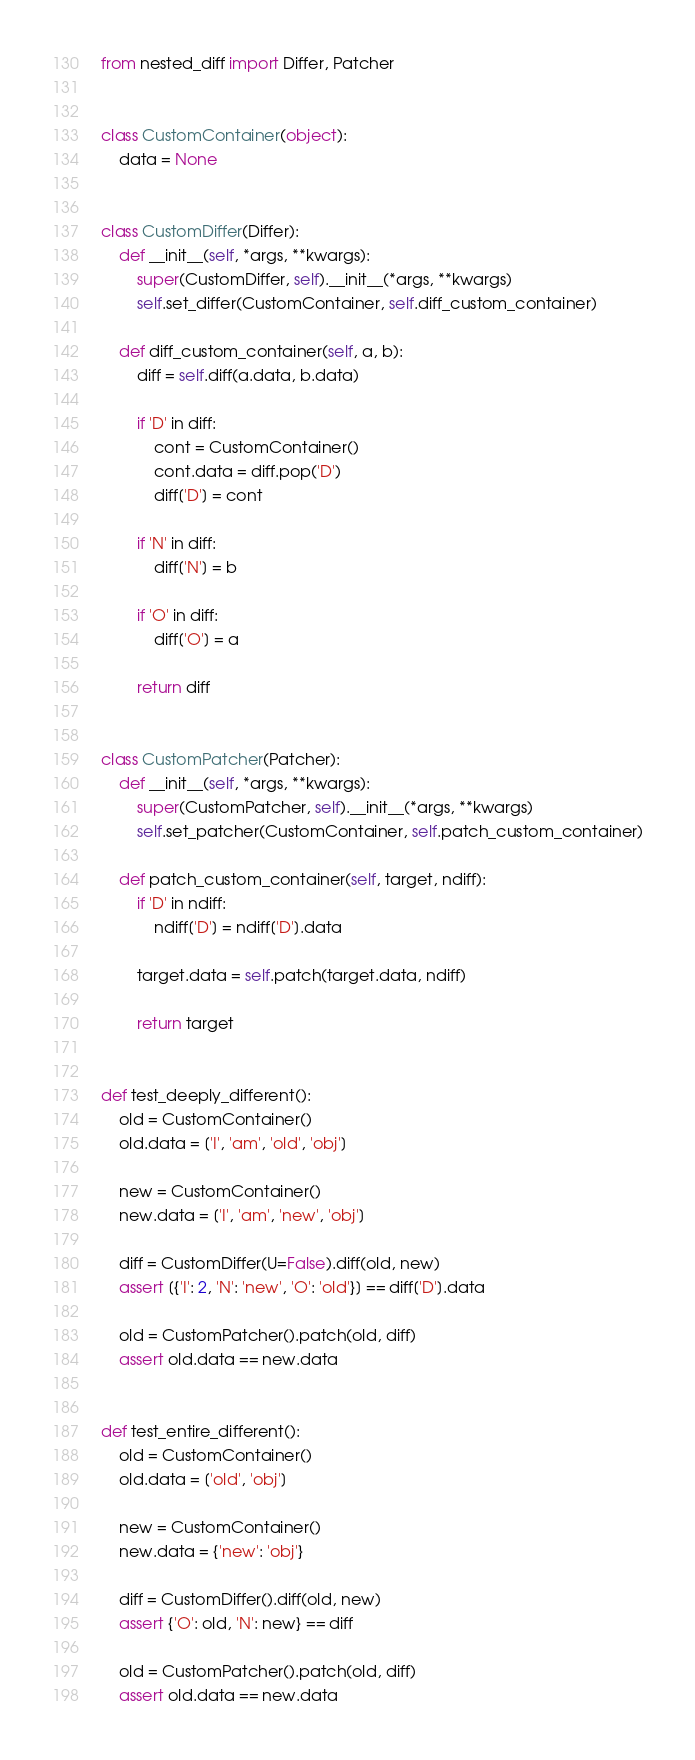Convert code to text. <code><loc_0><loc_0><loc_500><loc_500><_Python_>from nested_diff import Differ, Patcher


class CustomContainer(object):
    data = None


class CustomDiffer(Differ):
    def __init__(self, *args, **kwargs):
        super(CustomDiffer, self).__init__(*args, **kwargs)
        self.set_differ(CustomContainer, self.diff_custom_container)

    def diff_custom_container(self, a, b):
        diff = self.diff(a.data, b.data)

        if 'D' in diff:
            cont = CustomContainer()
            cont.data = diff.pop('D')
            diff['D'] = cont

        if 'N' in diff:
            diff['N'] = b

        if 'O' in diff:
            diff['O'] = a

        return diff


class CustomPatcher(Patcher):
    def __init__(self, *args, **kwargs):
        super(CustomPatcher, self).__init__(*args, **kwargs)
        self.set_patcher(CustomContainer, self.patch_custom_container)

    def patch_custom_container(self, target, ndiff):
        if 'D' in ndiff:
            ndiff['D'] = ndiff['D'].data

        target.data = self.patch(target.data, ndiff)

        return target


def test_deeply_different():
    old = CustomContainer()
    old.data = ['I', 'am', 'old', 'obj']

    new = CustomContainer()
    new.data = ['I', 'am', 'new', 'obj']

    diff = CustomDiffer(U=False).diff(old, new)
    assert [{'I': 2, 'N': 'new', 'O': 'old'}] == diff['D'].data

    old = CustomPatcher().patch(old, diff)
    assert old.data == new.data


def test_entire_different():
    old = CustomContainer()
    old.data = ['old', 'obj']

    new = CustomContainer()
    new.data = {'new': 'obj'}

    diff = CustomDiffer().diff(old, new)
    assert {'O': old, 'N': new} == diff

    old = CustomPatcher().patch(old, diff)
    assert old.data == new.data
</code> 